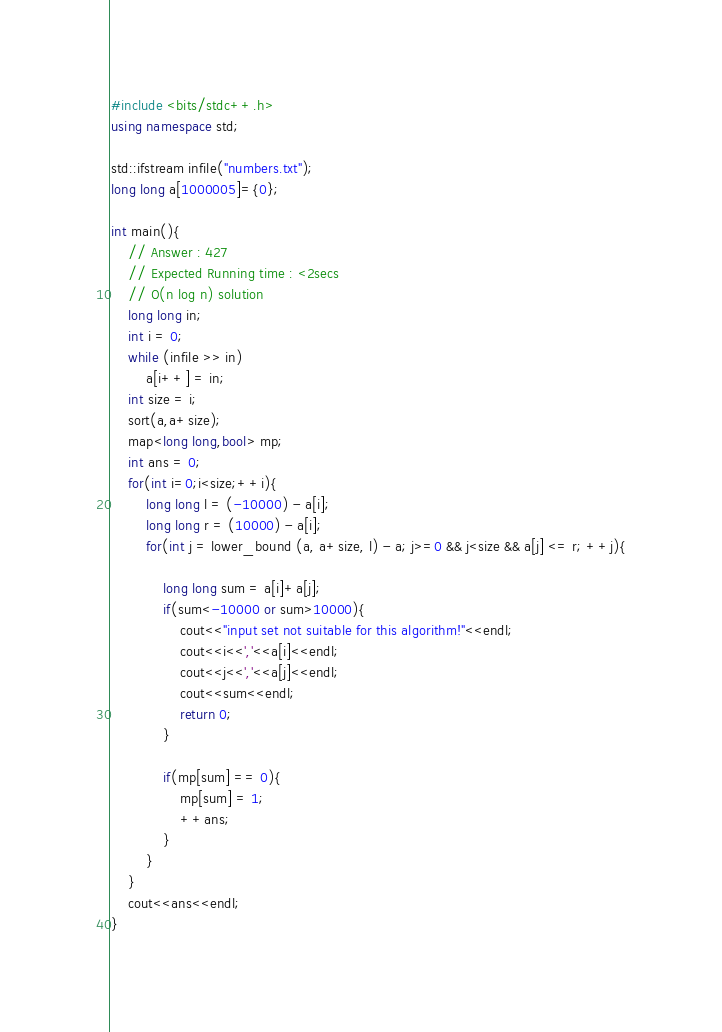<code> <loc_0><loc_0><loc_500><loc_500><_C++_>#include <bits/stdc++.h>
using namespace std;

std::ifstream infile("numbers.txt");
long long a[1000005]={0};

int main(){
	// Answer : 427
	// Expected Running time : <2secs
	// O(n log n) solution
	long long in;
	int i = 0;
	while (infile >> in)
		a[i++] = in;
	int size = i;
	sort(a,a+size);
	map<long long,bool> mp;
	int ans = 0;
	for(int i=0;i<size;++i){
		long long l = (-10000) - a[i];
		long long r = (10000) - a[i];
		for(int j = lower_bound (a, a+size, l) - a; j>=0 && j<size && a[j] <= r; ++j){
			
			long long sum = a[i]+a[j];
			if(sum<-10000 or sum>10000){
				cout<<"input set not suitable for this algorithm!"<<endl;
				cout<<i<<','<<a[i]<<endl;
				cout<<j<<','<<a[j]<<endl;
				cout<<sum<<endl;
				return 0;
			}

			if(mp[sum] == 0){
				mp[sum] = 1;
				++ans;
			}
		}
	}
	cout<<ans<<endl;
}</code> 